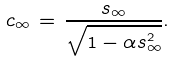Convert formula to latex. <formula><loc_0><loc_0><loc_500><loc_500>c _ { \infty } \, = \, \frac { s _ { \infty } } { \sqrt { 1 - \alpha s _ { \infty } ^ { 2 } } } .</formula> 